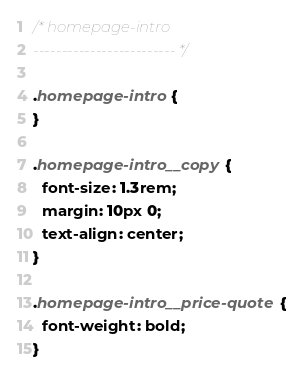<code> <loc_0><loc_0><loc_500><loc_500><_CSS_>/* homepage-intro
------------------------- */

.homepage-intro {
}

.homepage-intro__copy {
  font-size: 1.3rem;
  margin: 10px 0;
  text-align: center;
}

.homepage-intro__price-quote {
  font-weight: bold;
}
</code> 